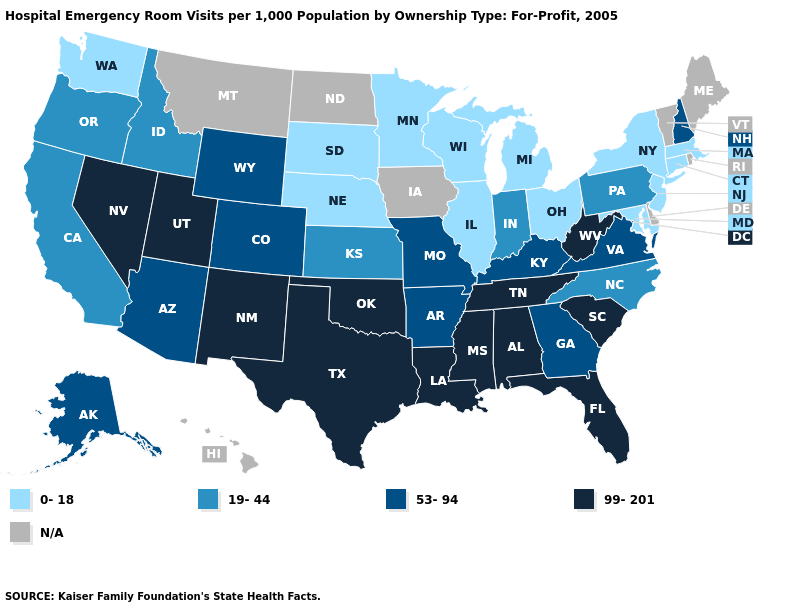Does the map have missing data?
Write a very short answer. Yes. Name the states that have a value in the range 99-201?
Concise answer only. Alabama, Florida, Louisiana, Mississippi, Nevada, New Mexico, Oklahoma, South Carolina, Tennessee, Texas, Utah, West Virginia. What is the value of Ohio?
Short answer required. 0-18. Is the legend a continuous bar?
Be succinct. No. Among the states that border Louisiana , does Texas have the highest value?
Write a very short answer. Yes. Does the first symbol in the legend represent the smallest category?
Keep it brief. Yes. Name the states that have a value in the range 0-18?
Quick response, please. Connecticut, Illinois, Maryland, Massachusetts, Michigan, Minnesota, Nebraska, New Jersey, New York, Ohio, South Dakota, Washington, Wisconsin. What is the value of Idaho?
Short answer required. 19-44. Name the states that have a value in the range 19-44?
Write a very short answer. California, Idaho, Indiana, Kansas, North Carolina, Oregon, Pennsylvania. Does Nevada have the highest value in the West?
Write a very short answer. Yes. Name the states that have a value in the range 53-94?
Keep it brief. Alaska, Arizona, Arkansas, Colorado, Georgia, Kentucky, Missouri, New Hampshire, Virginia, Wyoming. Name the states that have a value in the range 19-44?
Give a very brief answer. California, Idaho, Indiana, Kansas, North Carolina, Oregon, Pennsylvania. What is the value of Nevada?
Short answer required. 99-201. Which states have the lowest value in the West?
Concise answer only. Washington. 